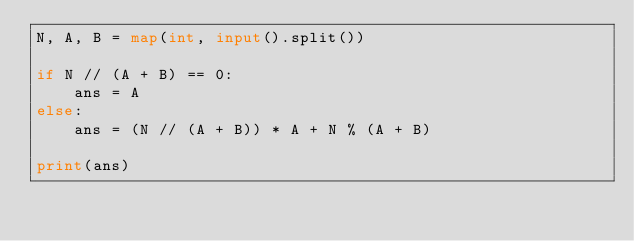<code> <loc_0><loc_0><loc_500><loc_500><_Python_>N, A, B = map(int, input().split())

if N // (A + B) == 0:
    ans = A
else:
    ans = (N // (A + B)) * A + N % (A + B)

print(ans)
</code> 